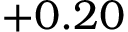Convert formula to latex. <formula><loc_0><loc_0><loc_500><loc_500>+ 0 . 2 0</formula> 